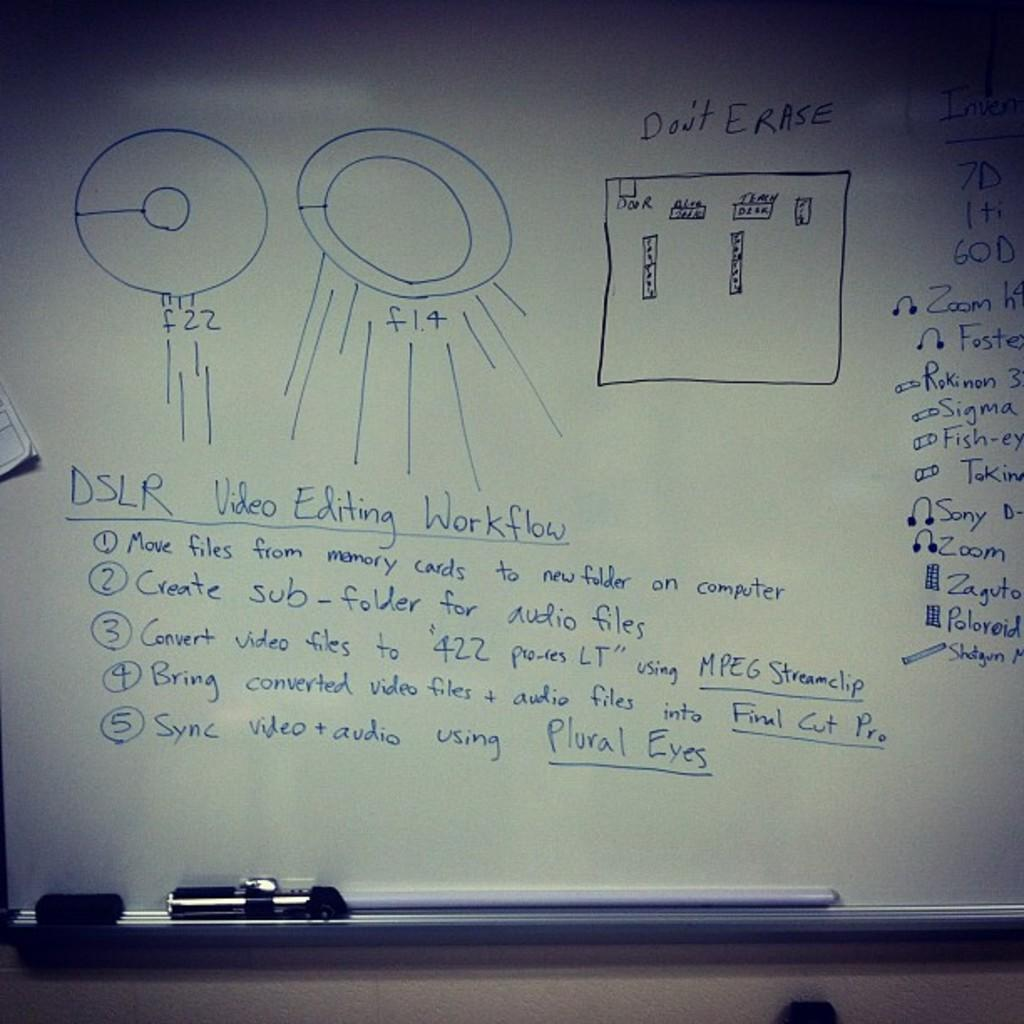<image>
Render a clear and concise summary of the photo. A whiteboard explains the steps to "DSLR Video Editing Workflow." 